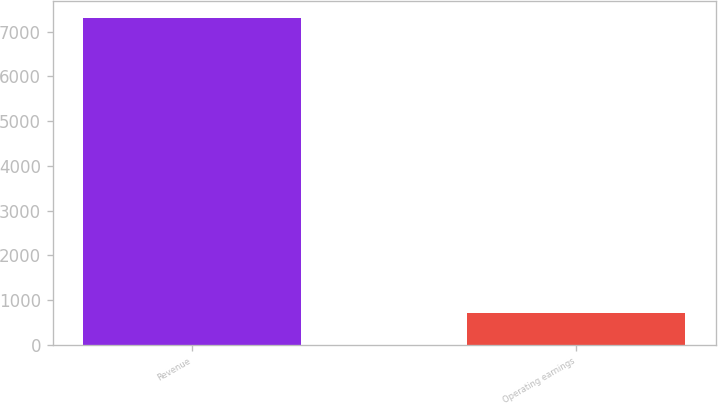Convert chart to OTSL. <chart><loc_0><loc_0><loc_500><loc_500><bar_chart><fcel>Revenue<fcel>Operating earnings<nl><fcel>7312<fcel>703<nl></chart> 